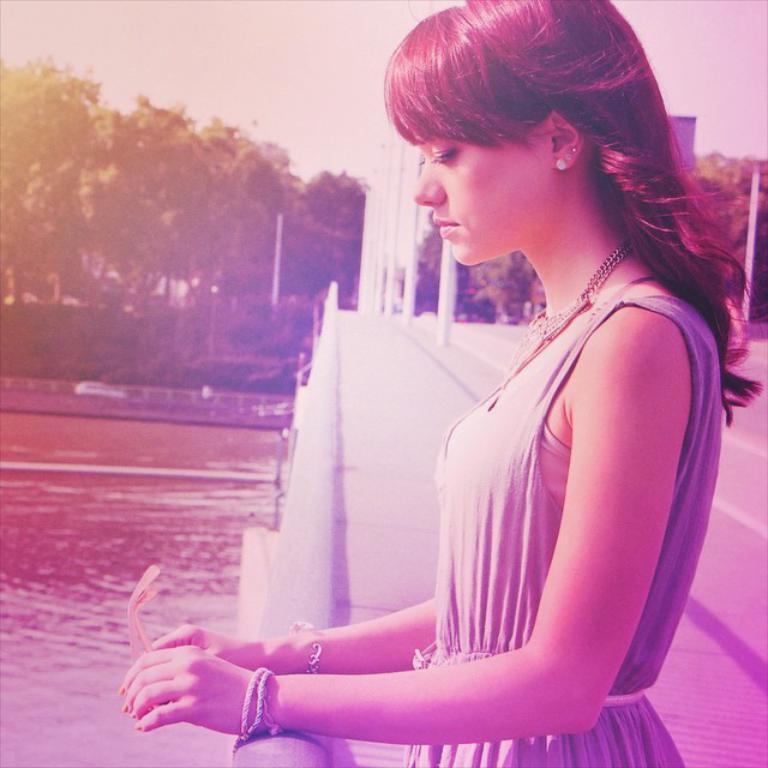Please provide a concise description of this image. In the picture we can see a woman standing near the railing on the bridge and looking into the water and in the background, we can see poles on the bridge and behind it we can see trees and sky. 